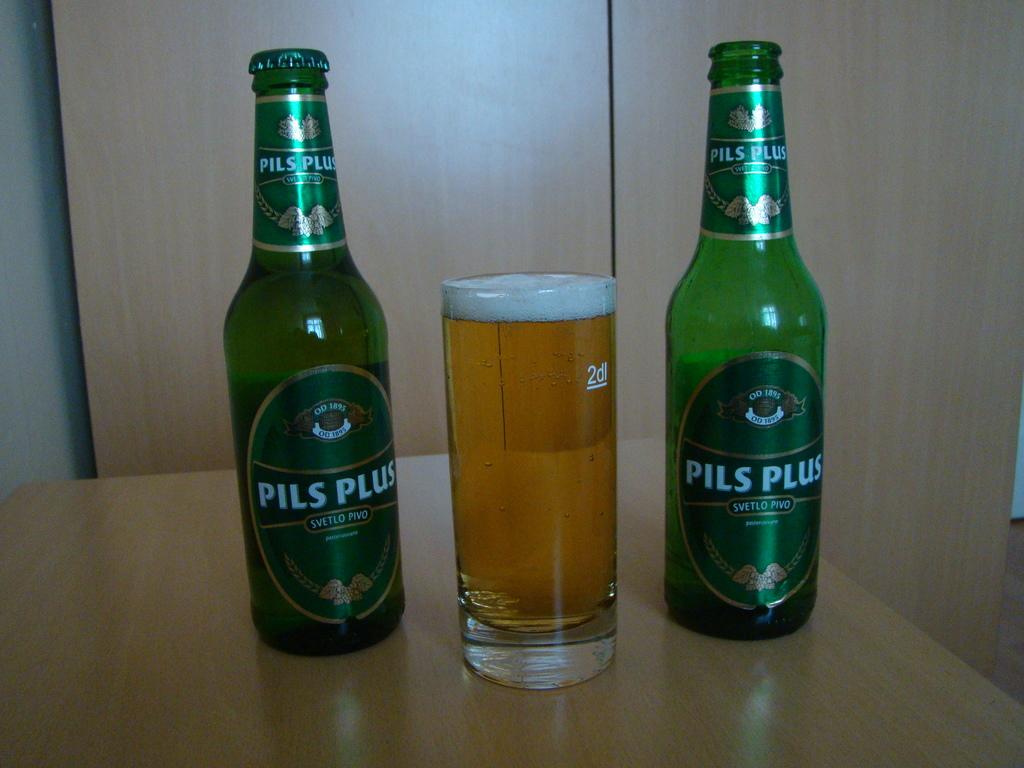What is the measurement on the glass?
Offer a terse response. 2dl. 